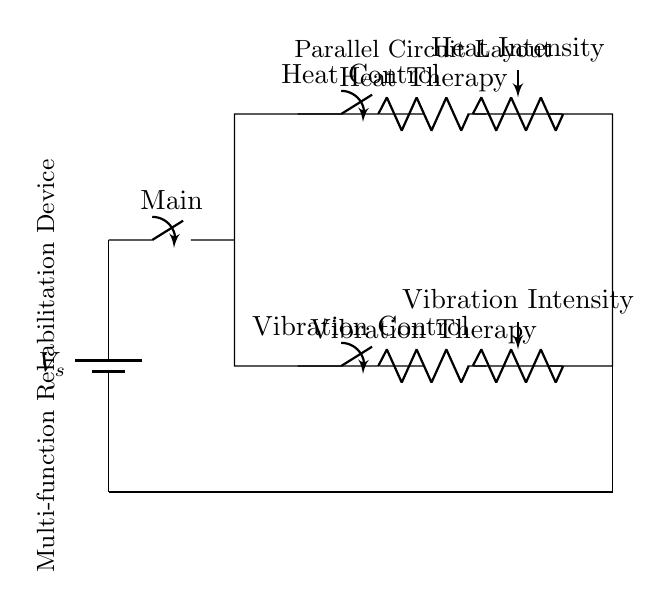What is shown at the power supply? The power supply is labeled as V_s, indicating the voltage source for the circuit.
Answer: V_s How many parallel branches are there? There are two parallel branches: one for Heat Therapy and one for Vibration Therapy, both connected to the same power supply.
Answer: Two What component controls the heating function? The component that controls the heating function is labeled as Heat Control, which is a switch.
Answer: Heat Control What type of circuit is this? This is a parallel circuit, as indicated by the multiple branches connected to a single voltage source.
Answer: Parallel What is the purpose of the variable resistor connected to heat? The variable resistor labeled as Heat Intensity is used to adjust the intensity of the heat therapy in the circuit.
Answer: Adjust intensity Which device provides vibration therapy? The component labeled as Vibration Therapy provides the vibration function in this circuit.
Answer: Vibration Therapy What is the ground connection in this circuit? The ground connection is represented by the lower line that connects to the bottom of the circuit, ensuring all components share a common reference point.
Answer: Ground 